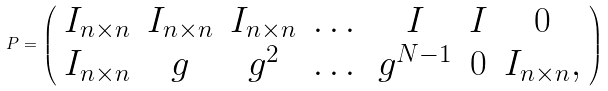<formula> <loc_0><loc_0><loc_500><loc_500>P = \left ( \begin{array} { c c c c c c c } I _ { n \times n } & I _ { n \times n } & I _ { n \times n } & \dots & I & I & 0 \\ I _ { n \times n } & g & g ^ { 2 } & \dots & g ^ { N - 1 } & 0 & I _ { n \times n } , \end{array} \right )</formula> 